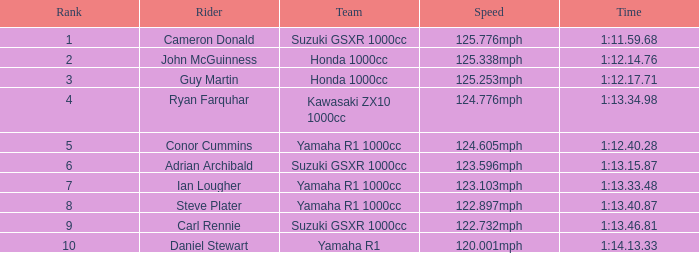What was the duration for team kawasaki zx10 1000cc? 1:13.34.98. Could you parse the entire table as a dict? {'header': ['Rank', 'Rider', 'Team', 'Speed', 'Time'], 'rows': [['1', 'Cameron Donald', 'Suzuki GSXR 1000cc', '125.776mph', '1:11.59.68'], ['2', 'John McGuinness', 'Honda 1000cc', '125.338mph', '1:12.14.76'], ['3', 'Guy Martin', 'Honda 1000cc', '125.253mph', '1:12.17.71'], ['4', 'Ryan Farquhar', 'Kawasaki ZX10 1000cc', '124.776mph', '1:13.34.98'], ['5', 'Conor Cummins', 'Yamaha R1 1000cc', '124.605mph', '1:12.40.28'], ['6', 'Adrian Archibald', 'Suzuki GSXR 1000cc', '123.596mph', '1:13.15.87'], ['7', 'Ian Lougher', 'Yamaha R1 1000cc', '123.103mph', '1:13.33.48'], ['8', 'Steve Plater', 'Yamaha R1 1000cc', '122.897mph', '1:13.40.87'], ['9', 'Carl Rennie', 'Suzuki GSXR 1000cc', '122.732mph', '1:13.46.81'], ['10', 'Daniel Stewart', 'Yamaha R1', '120.001mph', '1:14.13.33']]} 